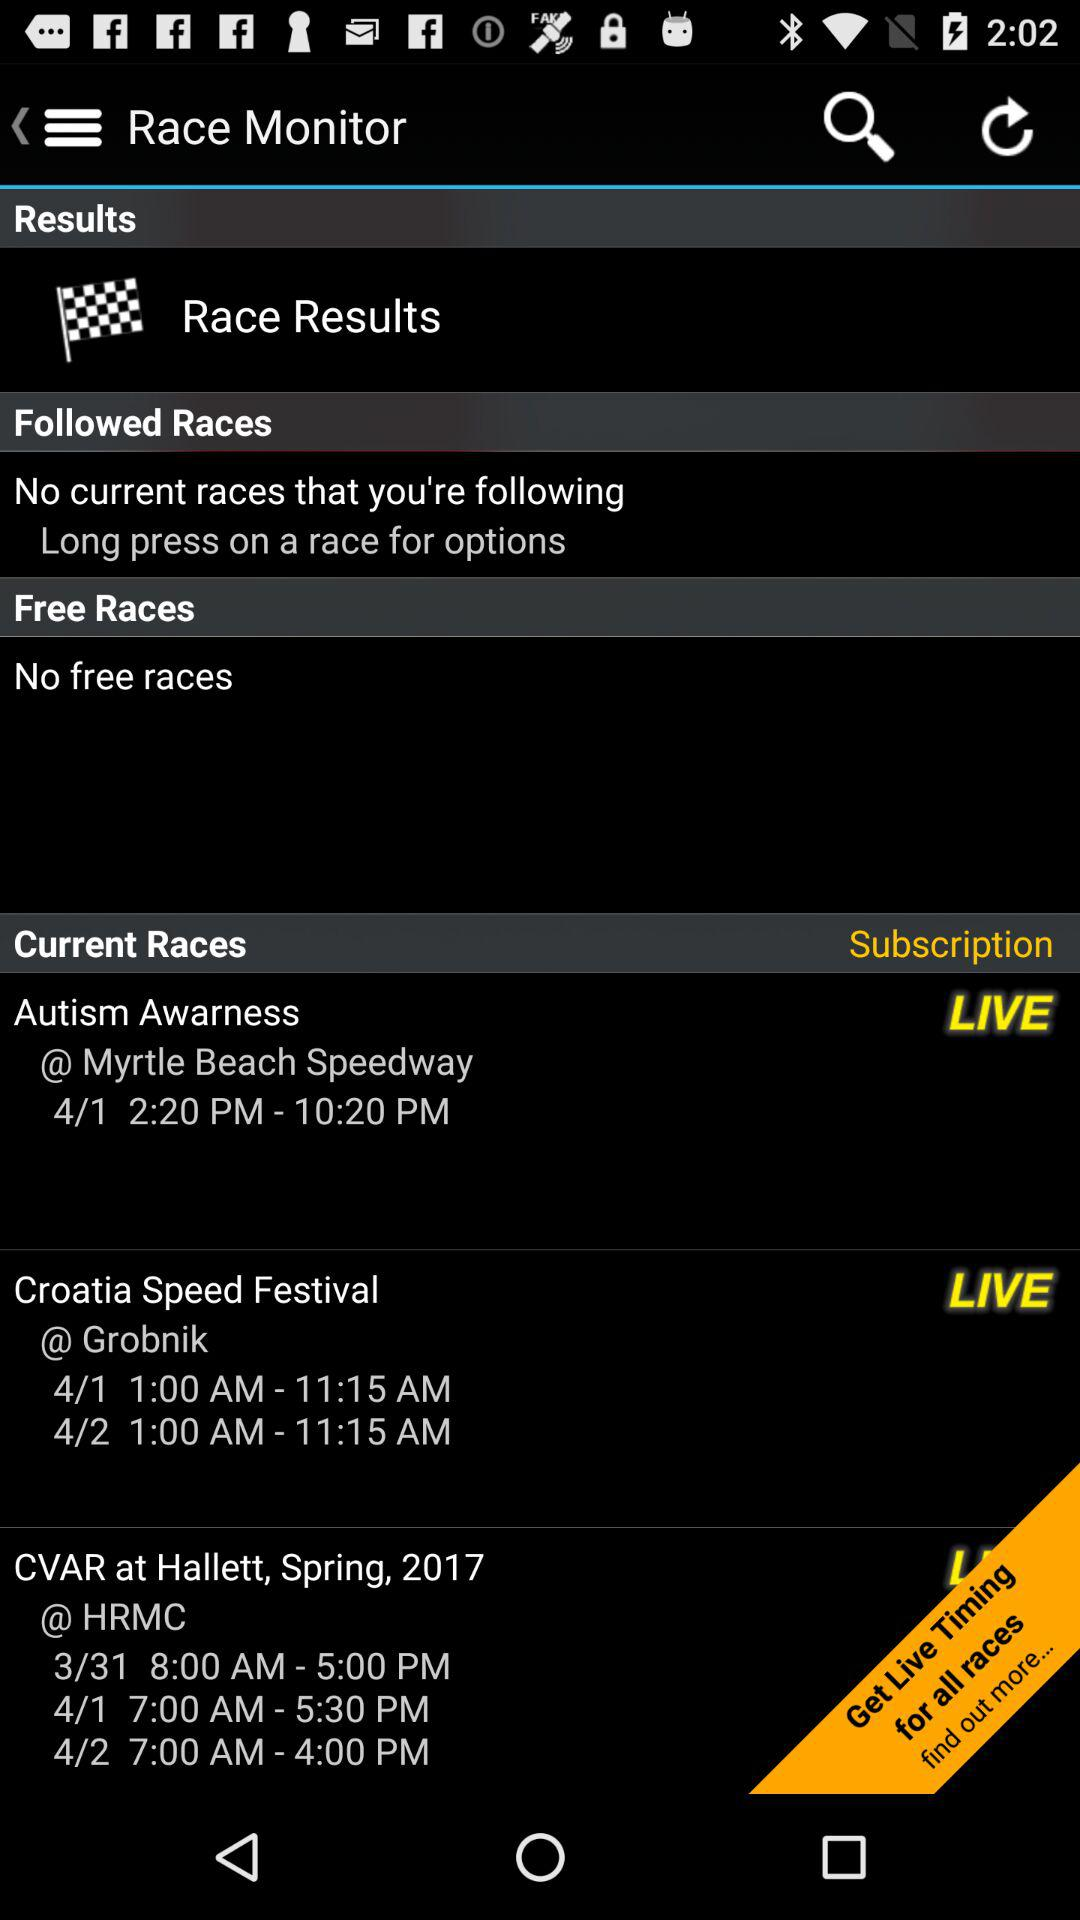What events are currently listed as 'LIVE' on the Race Monitor app? The events listed as 'LIVE' are the 'Autism Awareness' at Myrtle Beach Speedway and the 'Croatia Speed Festival' at Grobnik. 